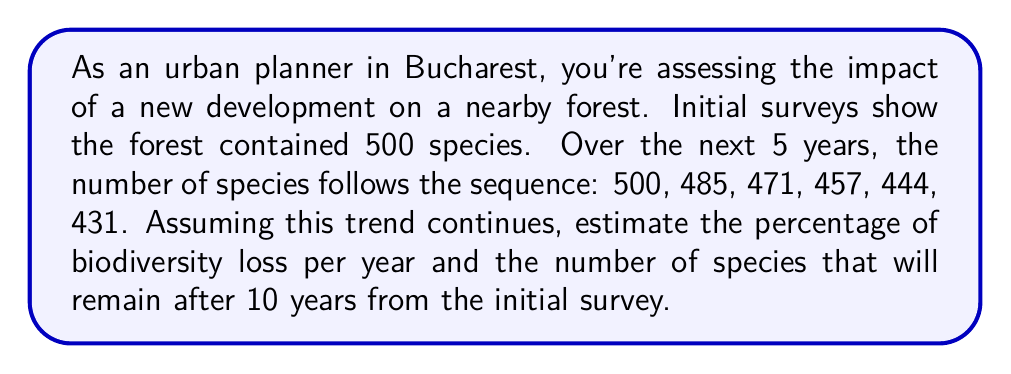Can you solve this math problem? 1. First, let's calculate the average decrease in species per year:
   Total decrease over 5 years = 500 - 431 = 69 species
   Average decrease per year = 69 ÷ 5 = 13.8 species/year

2. To calculate the percentage of biodiversity loss per year:
   Percentage loss = (Average decrease ÷ Initial number) × 100
   $$ \text{Percentage loss} = \frac{13.8}{500} \times 100 = 2.76\% $$

3. To estimate the number of species after 10 years:
   Total decrease over 10 years = 13.8 × 10 = 138 species
   Remaining species = 500 - 138 = 362 species

4. We can verify this using the geometric sequence formula:
   $$ a_n = a_1(1-r)^{n-1} $$
   Where $a_1$ is the initial value (500), $r$ is the rate of decrease (0.0276), and $n$ is the number of years plus 1.
   
   $$ a_{11} = 500(1-0.0276)^{10} \approx 362.3 $$

   This confirms our linear approximation.
Answer: 2.76% loss per year; 362 species after 10 years 